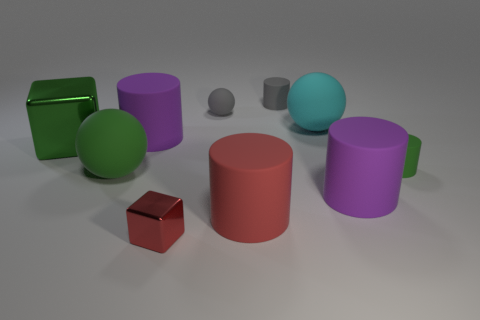How many purple cylinders must be subtracted to get 1 purple cylinders? 1 Subtract all gray spheres. How many spheres are left? 2 Subtract all big purple cylinders. How many cylinders are left? 3 Subtract 1 red blocks. How many objects are left? 9 Subtract all balls. How many objects are left? 7 Subtract 4 cylinders. How many cylinders are left? 1 Subtract all blue cylinders. Subtract all cyan spheres. How many cylinders are left? 5 Subtract all yellow cylinders. How many yellow spheres are left? 0 Subtract all tiny gray spheres. Subtract all large cyan matte spheres. How many objects are left? 8 Add 1 large purple rubber things. How many large purple rubber things are left? 3 